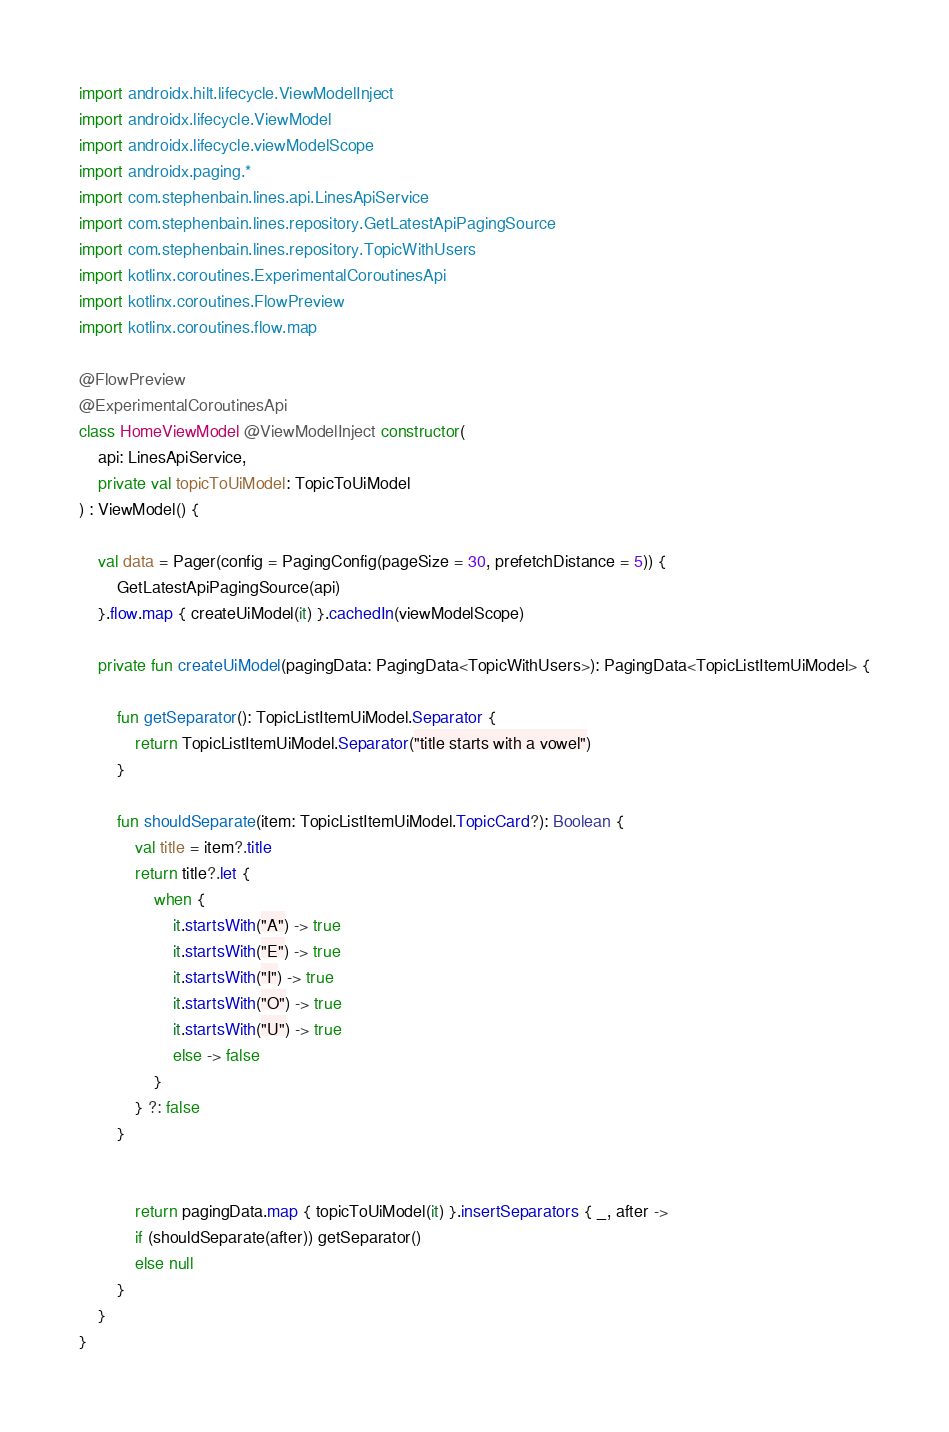Convert code to text. <code><loc_0><loc_0><loc_500><loc_500><_Kotlin_>import androidx.hilt.lifecycle.ViewModelInject
import androidx.lifecycle.ViewModel
import androidx.lifecycle.viewModelScope
import androidx.paging.*
import com.stephenbain.lines.api.LinesApiService
import com.stephenbain.lines.repository.GetLatestApiPagingSource
import com.stephenbain.lines.repository.TopicWithUsers
import kotlinx.coroutines.ExperimentalCoroutinesApi
import kotlinx.coroutines.FlowPreview
import kotlinx.coroutines.flow.map

@FlowPreview
@ExperimentalCoroutinesApi
class HomeViewModel @ViewModelInject constructor(
    api: LinesApiService,
    private val topicToUiModel: TopicToUiModel
) : ViewModel() {

    val data = Pager(config = PagingConfig(pageSize = 30, prefetchDistance = 5)) {
        GetLatestApiPagingSource(api)
    }.flow.map { createUiModel(it) }.cachedIn(viewModelScope)

    private fun createUiModel(pagingData: PagingData<TopicWithUsers>): PagingData<TopicListItemUiModel> {

        fun getSeparator(): TopicListItemUiModel.Separator {
            return TopicListItemUiModel.Separator("title starts with a vowel")
        }

        fun shouldSeparate(item: TopicListItemUiModel.TopicCard?): Boolean {
            val title = item?.title
            return title?.let {
                when {
                    it.startsWith("A") -> true
                    it.startsWith("E") -> true
                    it.startsWith("I") -> true
                    it.startsWith("O") -> true
                    it.startsWith("U") -> true
                    else -> false
                }
            } ?: false
        }


            return pagingData.map { topicToUiModel(it) }.insertSeparators { _, after ->
            if (shouldSeparate(after)) getSeparator()
            else null
        }
    }
}</code> 